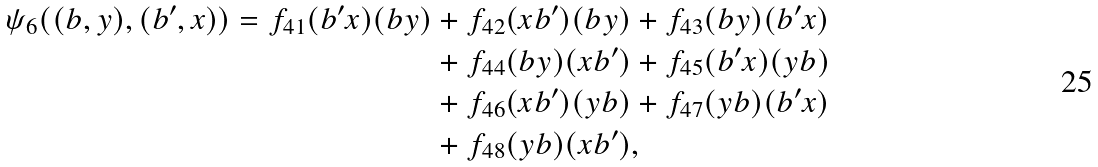Convert formula to latex. <formula><loc_0><loc_0><loc_500><loc_500>\psi _ { 6 } ( ( b , y ) , ( b ^ { \prime } , x ) ) = f _ { 4 1 } ( b ^ { \prime } x ) ( b y ) & + f _ { 4 2 } ( x b ^ { \prime } ) ( b y ) + f _ { 4 3 } ( b y ) ( b ^ { \prime } x ) \\ & + f _ { 4 4 } ( b y ) ( x b ^ { \prime } ) + f _ { 4 5 } ( b ^ { \prime } x ) ( y b ) \\ & + f _ { 4 6 } ( x b ^ { \prime } ) ( y b ) + f _ { 4 7 } ( y b ) ( b ^ { \prime } x ) \\ & + f _ { 4 8 } ( y b ) ( x b ^ { \prime } ) ,</formula> 